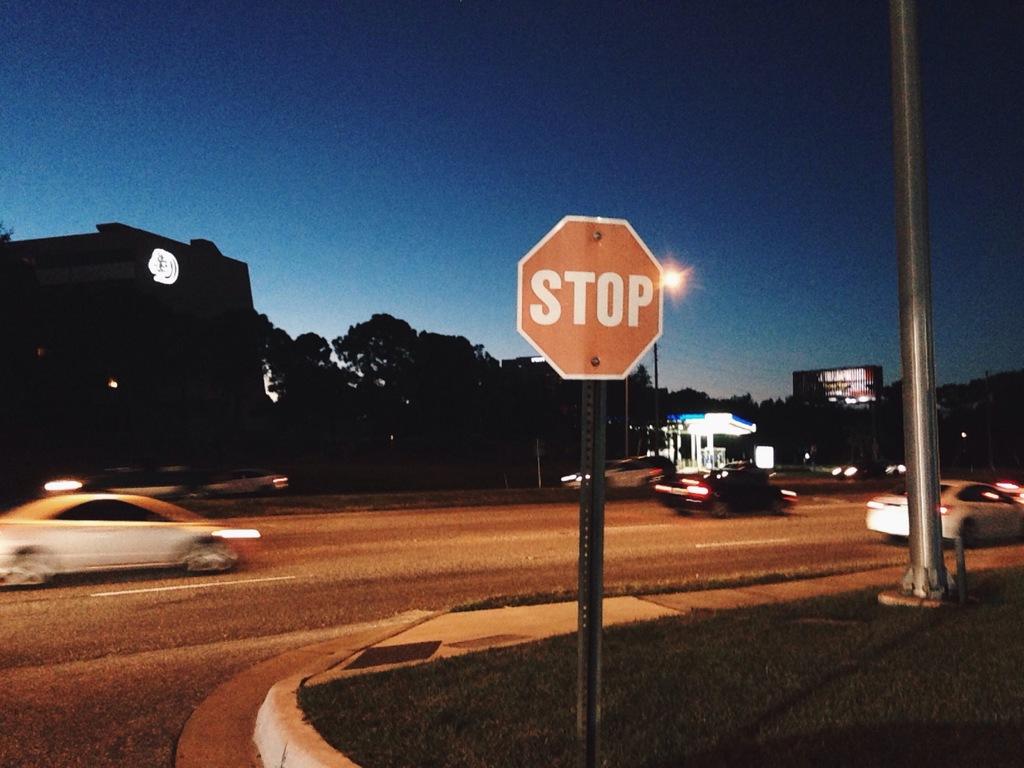What does the sign say?
Keep it short and to the point. Stop. 